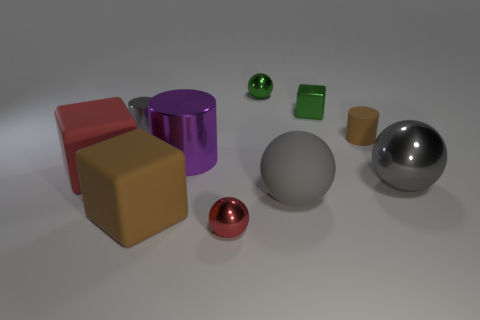What is the color of the other sphere that is the same size as the gray rubber sphere?
Make the answer very short. Gray. What number of matte cubes are to the right of the gray metallic cylinder and on the left side of the small gray thing?
Offer a terse response. 0. What is the shape of the thing that is the same color as the rubber cylinder?
Your answer should be compact. Cube. What material is the tiny thing that is both behind the big red object and in front of the gray cylinder?
Your answer should be compact. Rubber. Is the number of cylinders that are behind the large purple metal cylinder less than the number of green cubes behind the tiny green metallic sphere?
Make the answer very short. No. There is a red object that is made of the same material as the green cube; what size is it?
Ensure brevity in your answer.  Small. Is there anything else of the same color as the small metal cube?
Ensure brevity in your answer.  Yes. Are the green ball and the brown object on the right side of the brown block made of the same material?
Make the answer very short. No. What material is the large brown thing that is the same shape as the red matte object?
Ensure brevity in your answer.  Rubber. Is the material of the red thing that is right of the purple shiny cylinder the same as the tiny cylinder on the right side of the brown cube?
Give a very brief answer. No. 